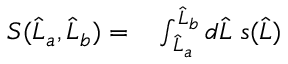Convert formula to latex. <formula><loc_0><loc_0><loc_500><loc_500>\begin{array} { r l r } { S ( \widehat { L } _ { a } , \widehat { L } _ { b } ) = } & \int _ { \widehat { L } _ { a } } ^ { \widehat { L } _ { b } } d \widehat { L } \, s ( \widehat { L } ) } \end{array}</formula> 